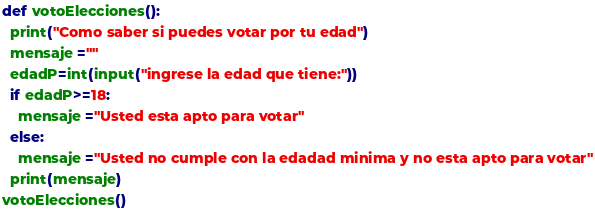Convert code to text. <code><loc_0><loc_0><loc_500><loc_500><_Python_>def votoElecciones():
  print("Como saber si puedes votar por tu edad")
  mensaje =""
  edadP=int(input("ingrese la edad que tiene:"))
  if edadP>=18:
    mensaje ="Usted esta apto para votar"
  else:
    mensaje ="Usted no cumple con la edadad minima y no esta apto para votar"
  print(mensaje)
votoElecciones()</code> 